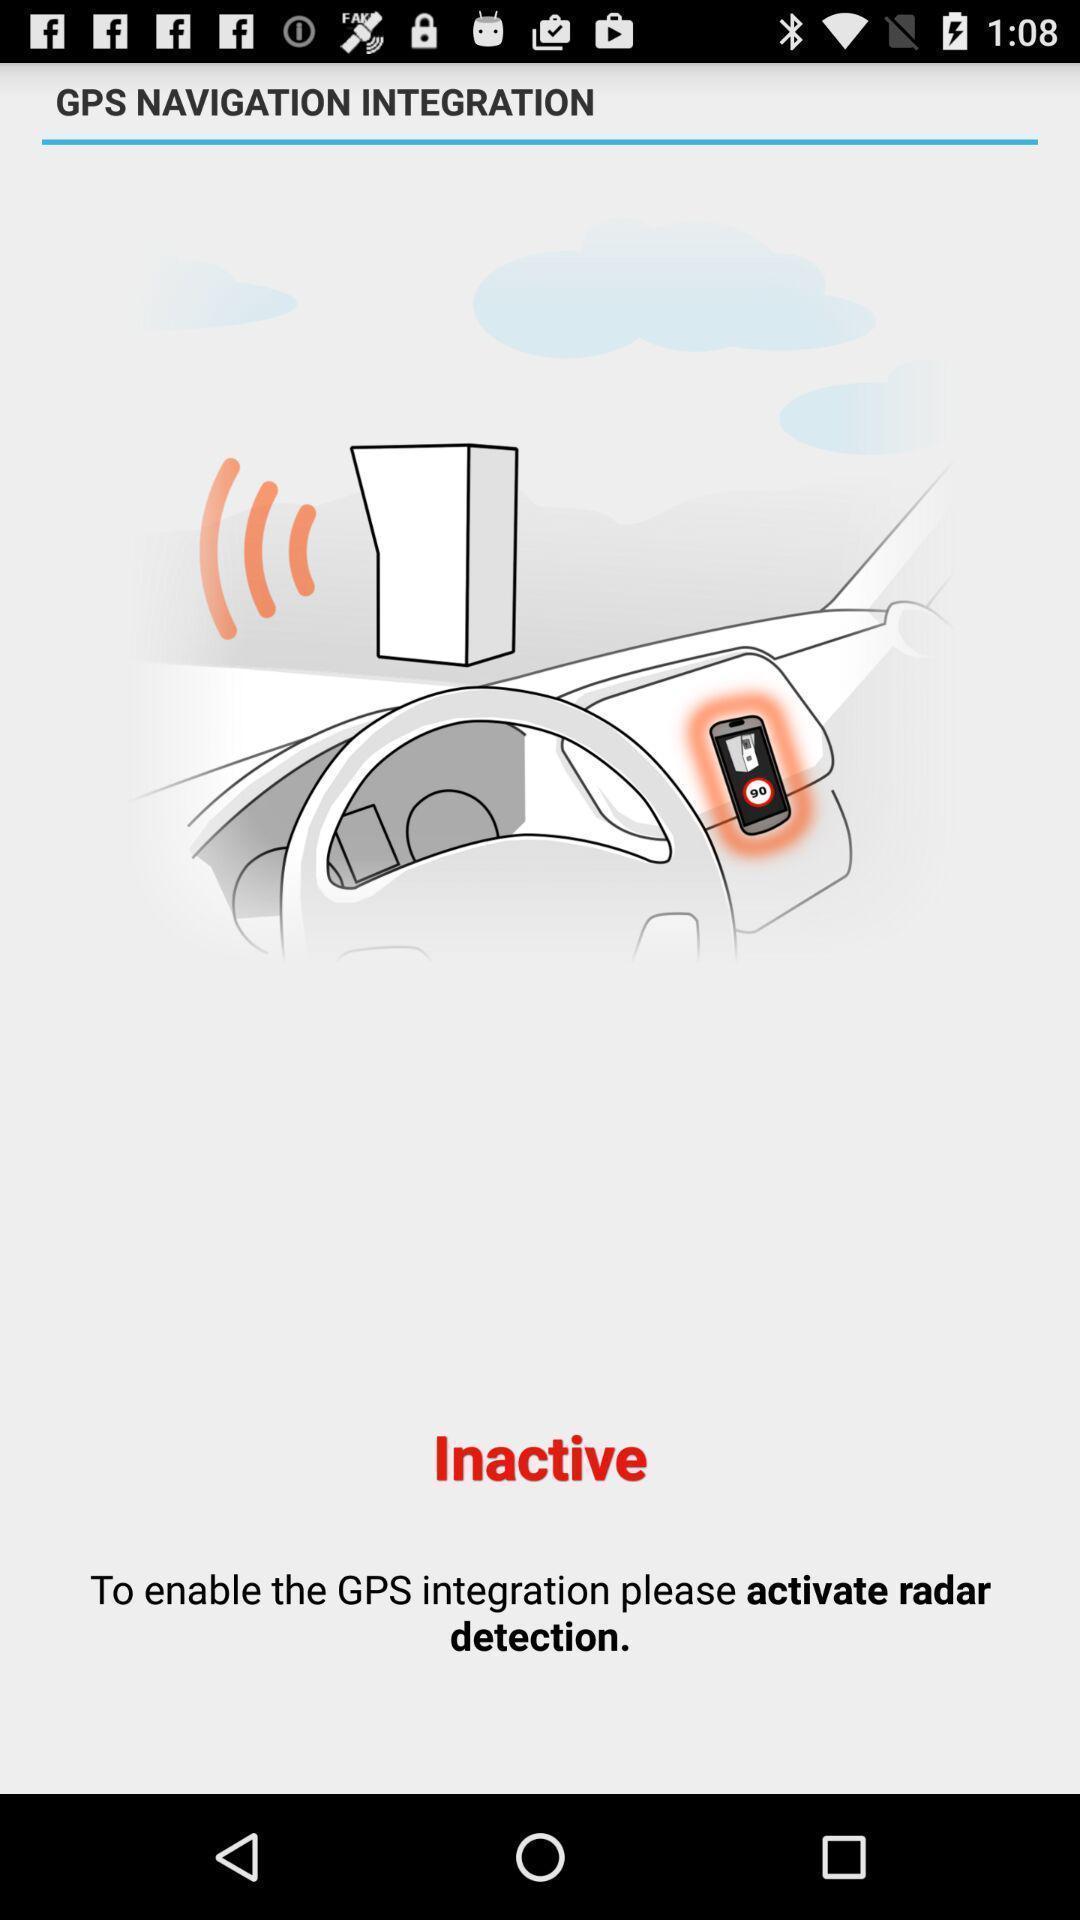Describe the content in this image. Welcome page of a gps app. 